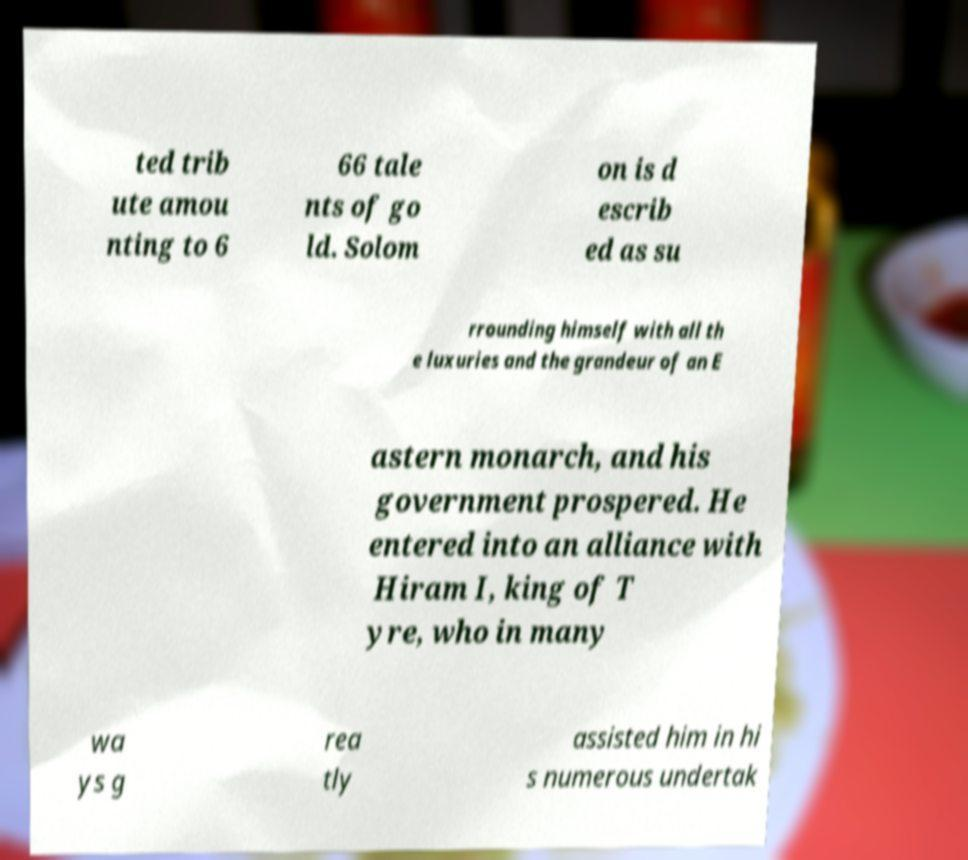I need the written content from this picture converted into text. Can you do that? ted trib ute amou nting to 6 66 tale nts of go ld. Solom on is d escrib ed as su rrounding himself with all th e luxuries and the grandeur of an E astern monarch, and his government prospered. He entered into an alliance with Hiram I, king of T yre, who in many wa ys g rea tly assisted him in hi s numerous undertak 